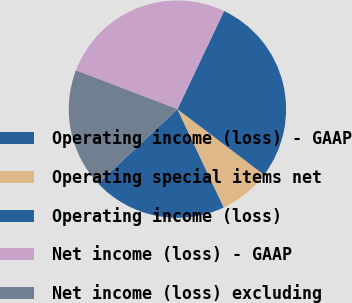Convert chart. <chart><loc_0><loc_0><loc_500><loc_500><pie_chart><fcel>Operating income (loss) - GAAP<fcel>Operating special items net<fcel>Operating income (loss)<fcel>Net income (loss) - GAAP<fcel>Net income (loss) excluding<nl><fcel>20.02%<fcel>7.67%<fcel>28.25%<fcel>26.25%<fcel>17.8%<nl></chart> 